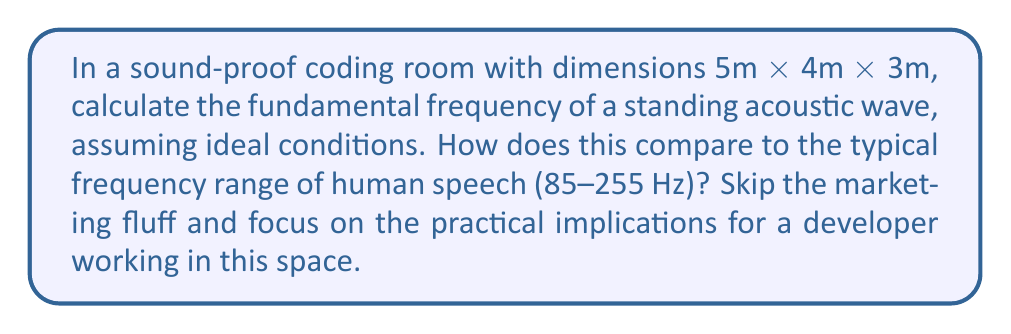Help me with this question. Let's approach this problem step-by-step, focusing on the practical aspects without any unnecessary embellishment:

1) The fundamental frequency of a standing wave in a rectangular room is given by:

   $$f = \frac{c}{2} \sqrt{\left(\frac{n_x}{L_x}\right)^2 + \left(\frac{n_y}{L_y}\right)^2 + \left(\frac{n_z}{L_z}\right)^2}$$

   Where:
   - $c$ is the speed of sound in air (approximately 343 m/s at room temperature)
   - $L_x$, $L_y$, and $L_z$ are the room dimensions
   - $n_x$, $n_y$, and $n_z$ are the mode numbers (1, 1, 1 for the fundamental frequency)

2) Plugging in our values:

   $$f = \frac{343}{2} \sqrt{\left(\frac{1}{5}\right)^2 + \left(\frac{1}{4}\right)^2 + \left(\frac{1}{3}\right)^2}$$

3) Simplifying:

   $$f = 171.5 \sqrt{0.04 + 0.0625 + 0.1111}$$
   $$f = 171.5 \sqrt{0.2136}$$
   $$f = 171.5 * 0.4622$$
   $$f \approx 79.27 \text{ Hz}$$

4) Comparing to human speech range (85-255 Hz):
   The fundamental frequency (79.27 Hz) is slightly below the typical range of human speech.

5) Practical implications:
   - The room's dimensions create a fundamental frequency that's close to, but just below, the lower end of human speech.
   - This could potentially lead to a slight emphasis on lower frequencies, which might affect how a developer perceives their own voice or audio playback in the room.
   - However, the difference is minimal, and higher harmonics will fall within the speech range, so the overall effect on work environment should be negligible.
   - The sound-proofing is likely to have a more significant impact on the developer's working conditions than these subtle acoustic properties.
Answer: 79.27 Hz; slightly below human speech range, minimal practical impact 